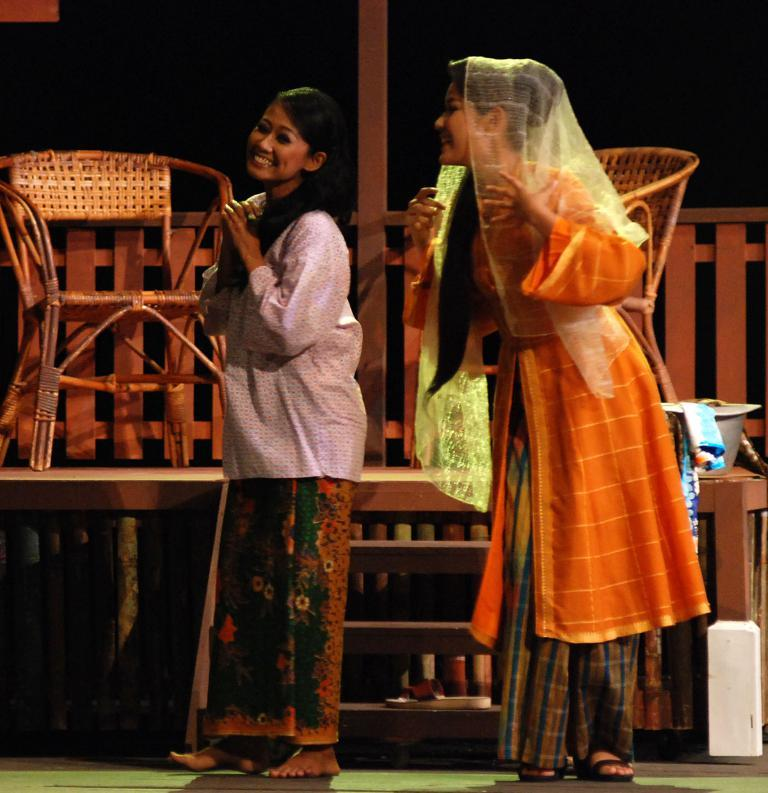How many women are present in the image? There are two women standing in the image. What type of chairs can be seen in the image? There are wooden chairs in the image. Can you describe the seating arrangement in the image? There is a chair in the image, which is likely one of the wooden chairs. What architectural feature is visible in the image? There are stairs in the image. How far away is the farmer from the women in the image? There is no farmer present in the image, so it is not possible to determine the distance between a farmer and the women. 